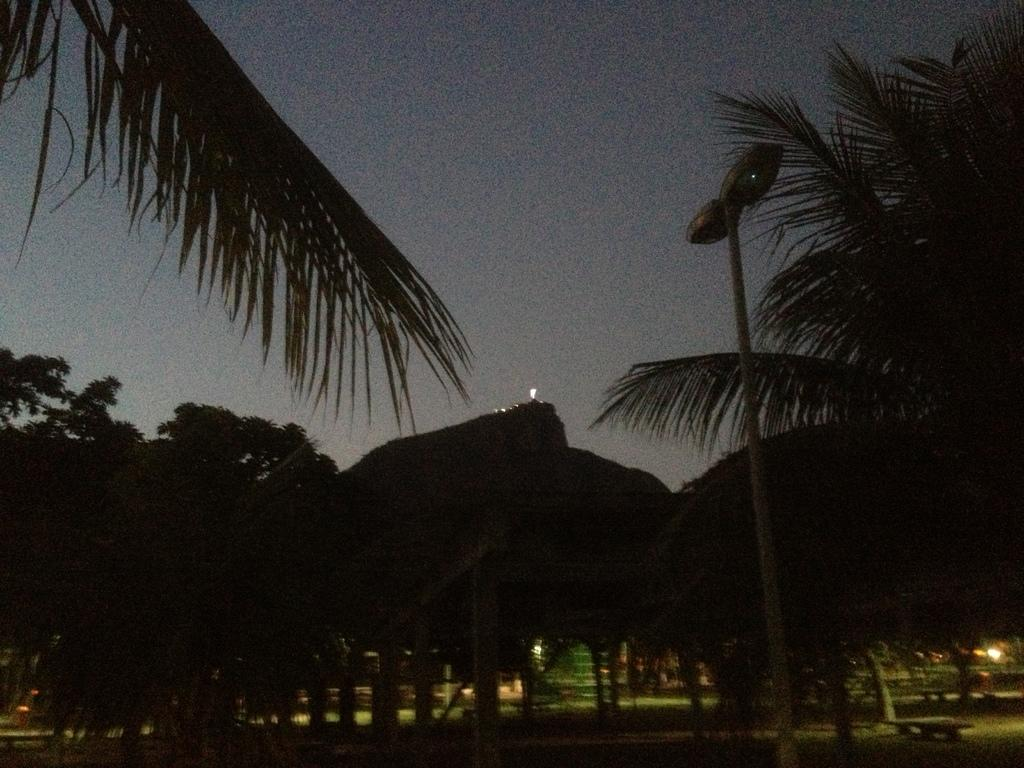What type of natural elements can be seen in the image? There are trees in the image. What is attached to the pole in the image? There are lights on a pole in the image. How would you describe the sky in the image? The sky appears to be cloudy in the image. Can you identify any sources of light in the image? Yes, there are lights visible in the image. How many women are jumping in the image? There are no women or jumping depicted in the image. 